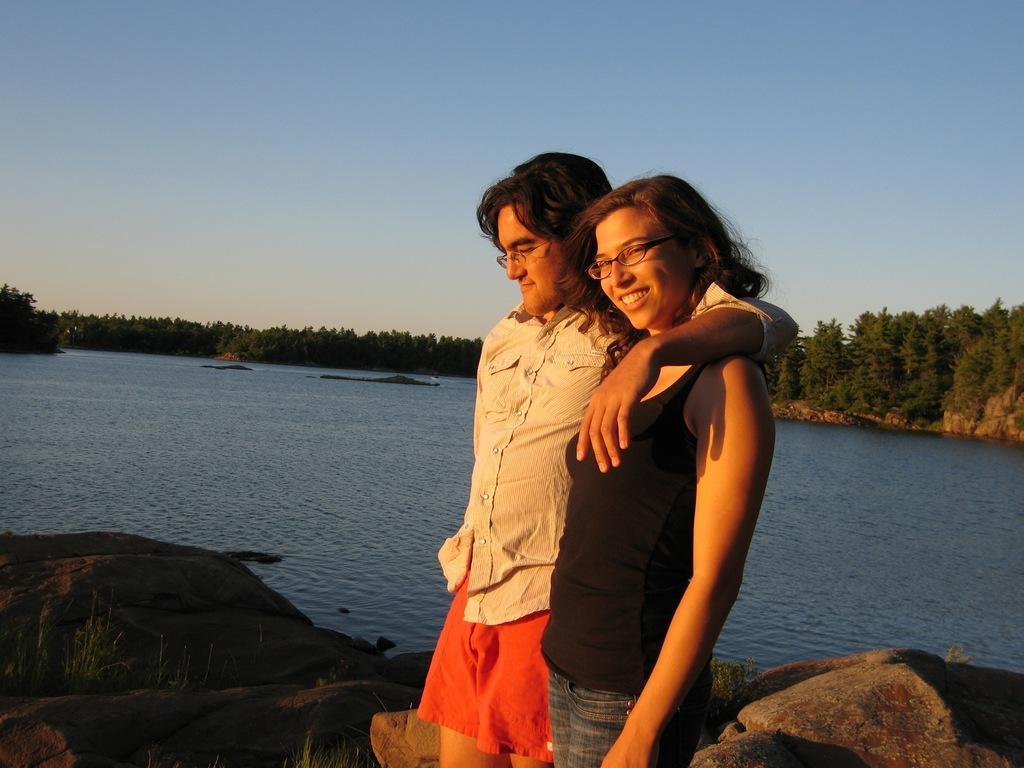Please provide a concise description of this image. In the center of the image we can see a lady and a man standing. In the background there is a river and we can see rocks. There are trees. At the top there is sky. 